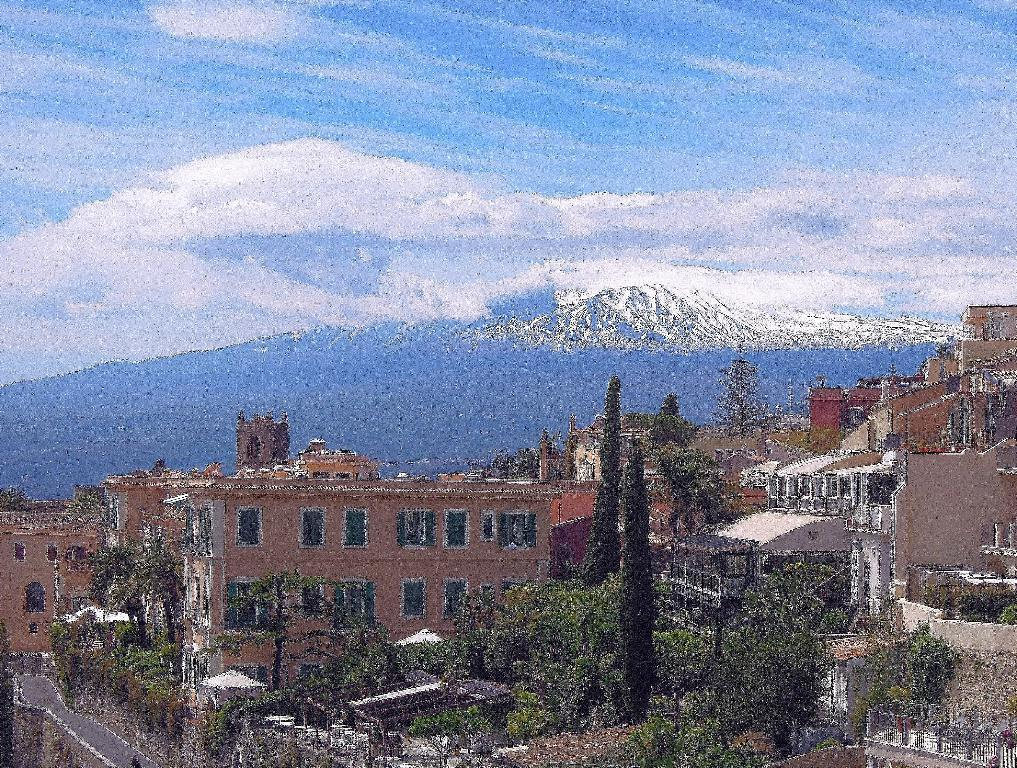What can be seen at the bottom of the image? Buildings, trees, walls, windows, poles, and a road are visible at the bottom of the image. What type of vegetation is present at the bottom of the image? Trees are present at the bottom of the image. What architectural features can be seen at the bottom of the image? Buildings, walls, and windows are visible at the bottom of the image. What is the condition of the sky in the background of the image? The sky is cloudy in the background of the image. What is the terrain like in the background of the image? There is a hill in the background of the image. What type of tray is being used to carry the whip in the image? There is no tray or whip present in the image. How many trips does it take to reach the top of the hill in the image? The image does not provide information about the distance or difficulty of the hill, so it is impossible to determine the number of trips required to reach the top. 